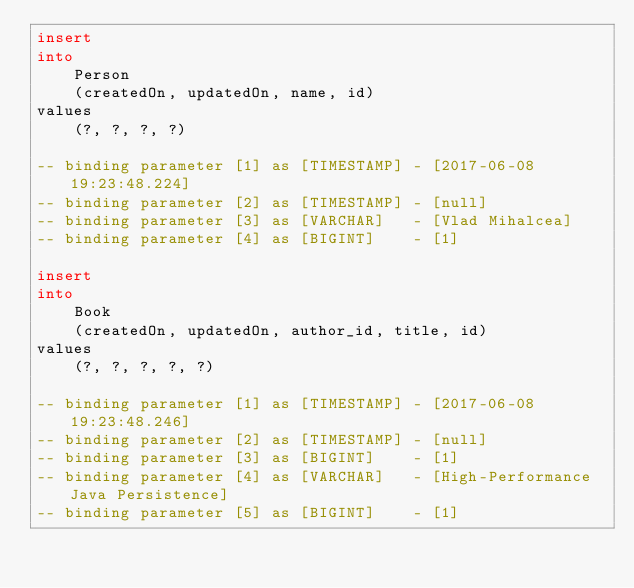Convert code to text. <code><loc_0><loc_0><loc_500><loc_500><_SQL_>insert
into
    Person
    (createdOn, updatedOn, name, id)
values
    (?, ?, ?, ?)

-- binding parameter [1] as [TIMESTAMP] - [2017-06-08 19:23:48.224]
-- binding parameter [2] as [TIMESTAMP] - [null]
-- binding parameter [3] as [VARCHAR]   - [Vlad Mihalcea]
-- binding parameter [4] as [BIGINT]    - [1]

insert
into
    Book
    (createdOn, updatedOn, author_id, title, id)
values
    (?, ?, ?, ?, ?)

-- binding parameter [1] as [TIMESTAMP] - [2017-06-08 19:23:48.246]
-- binding parameter [2] as [TIMESTAMP] - [null]
-- binding parameter [3] as [BIGINT]    - [1]
-- binding parameter [4] as [VARCHAR]   - [High-Performance Java Persistence]
-- binding parameter [5] as [BIGINT]    - [1]</code> 